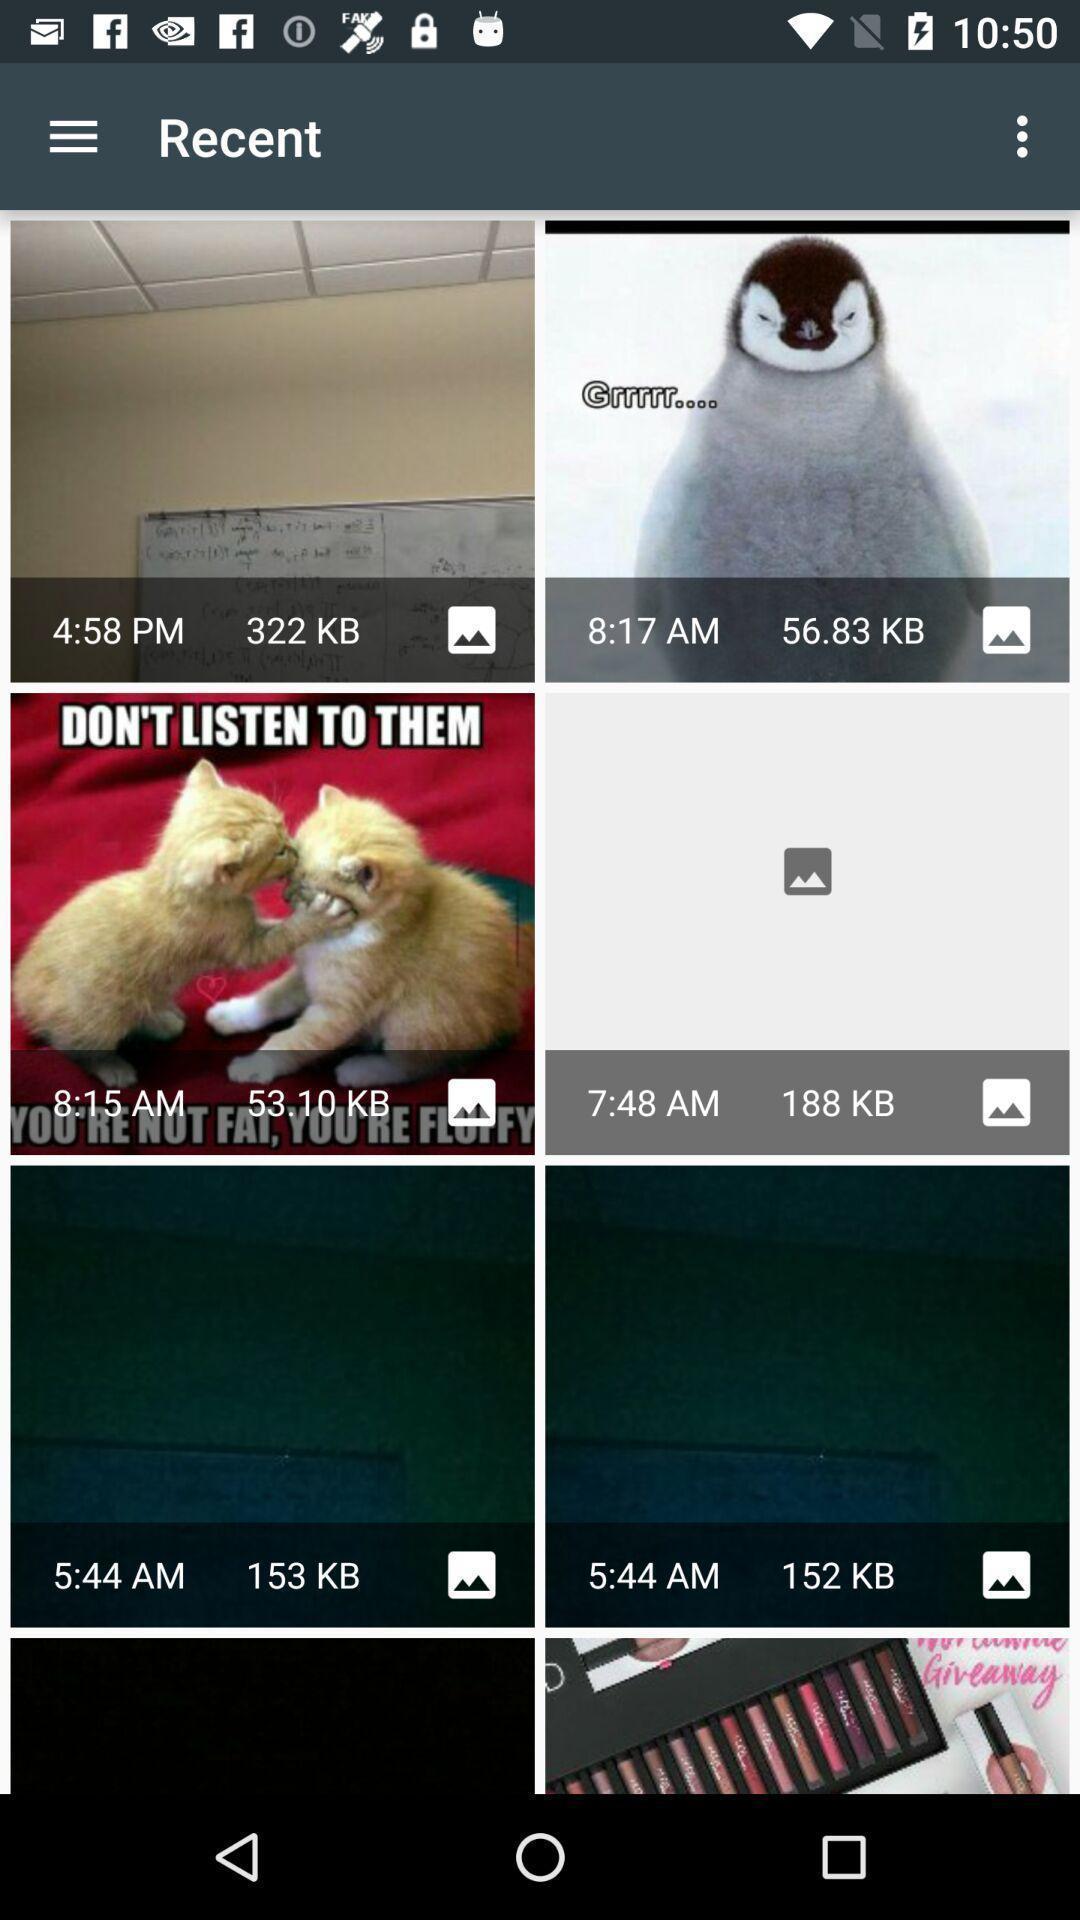Give me a summary of this screen capture. Pictures page in a beauty app. 